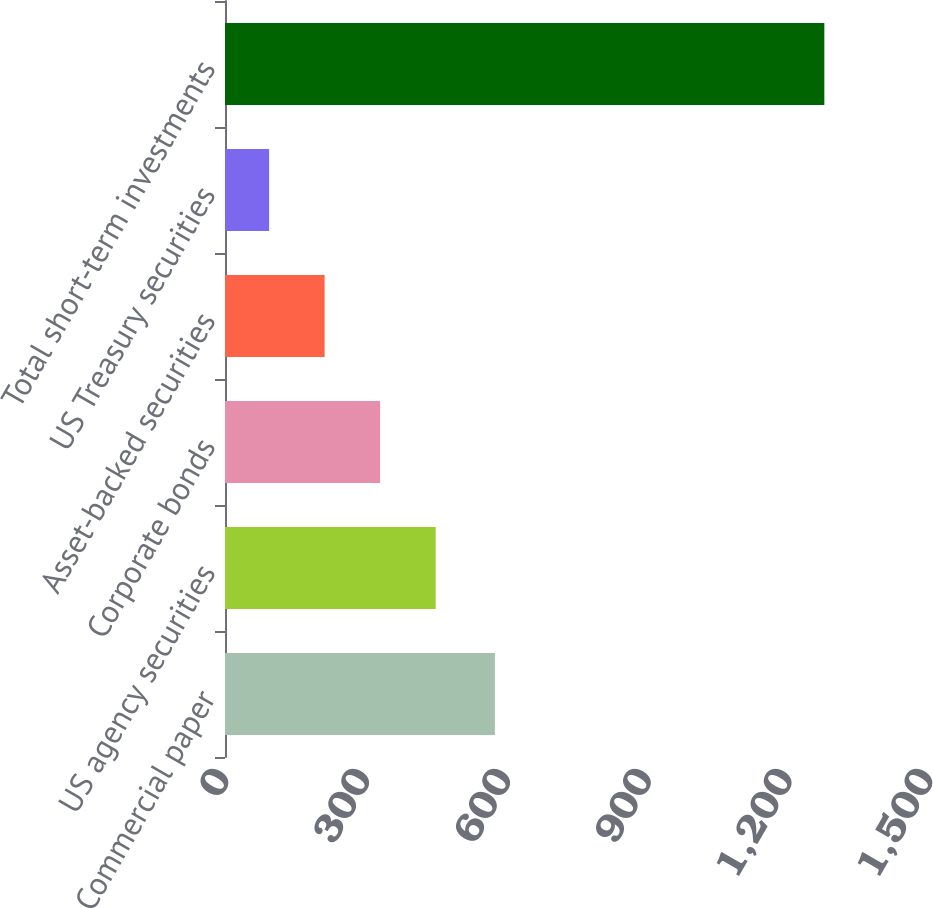<chart> <loc_0><loc_0><loc_500><loc_500><bar_chart><fcel>Commercial paper<fcel>US agency securities<fcel>Corporate bonds<fcel>Asset-backed securities<fcel>US Treasury securities<fcel>Total short-term investments<nl><fcel>575<fcel>448.9<fcel>330.6<fcel>212.3<fcel>94<fcel>1277<nl></chart> 